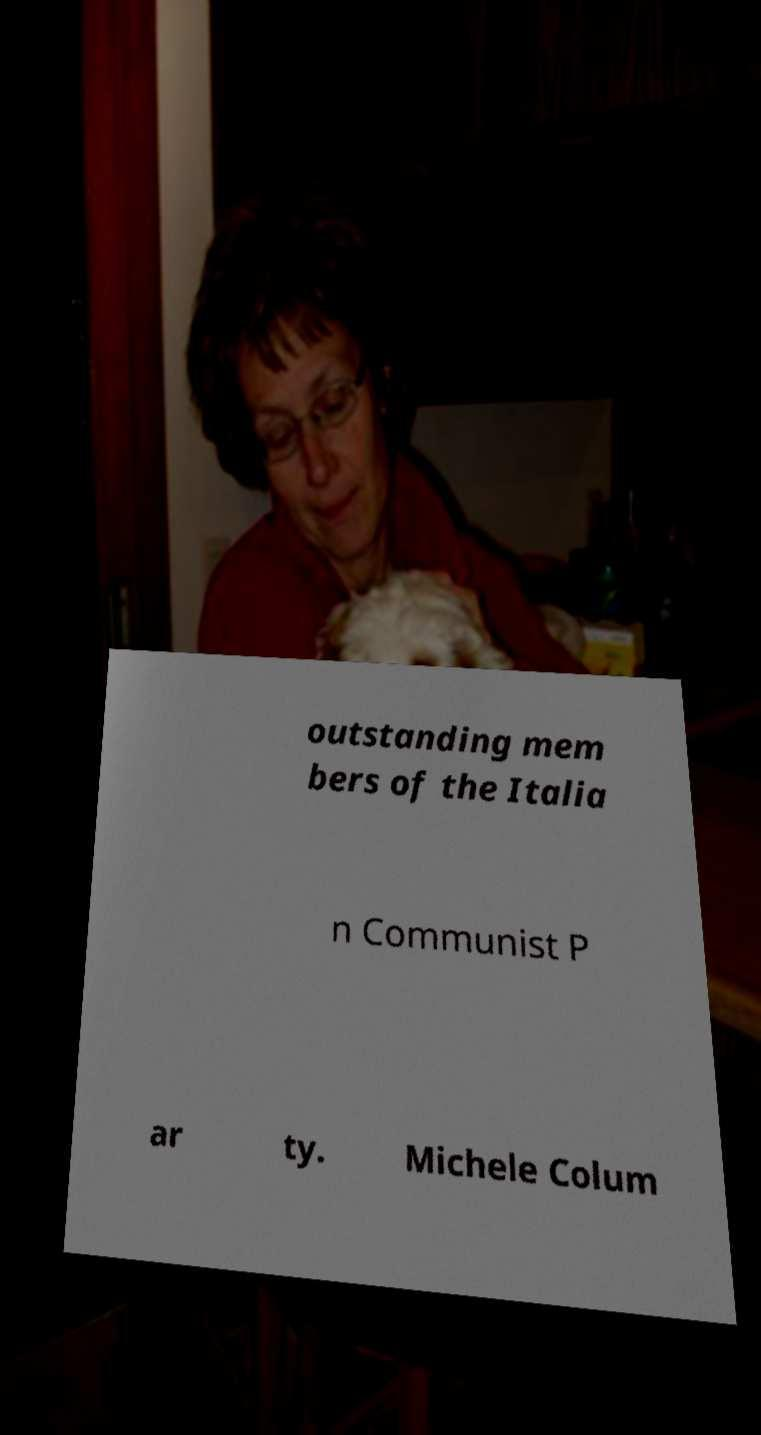Please read and relay the text visible in this image. What does it say? outstanding mem bers of the Italia n Communist P ar ty. Michele Colum 